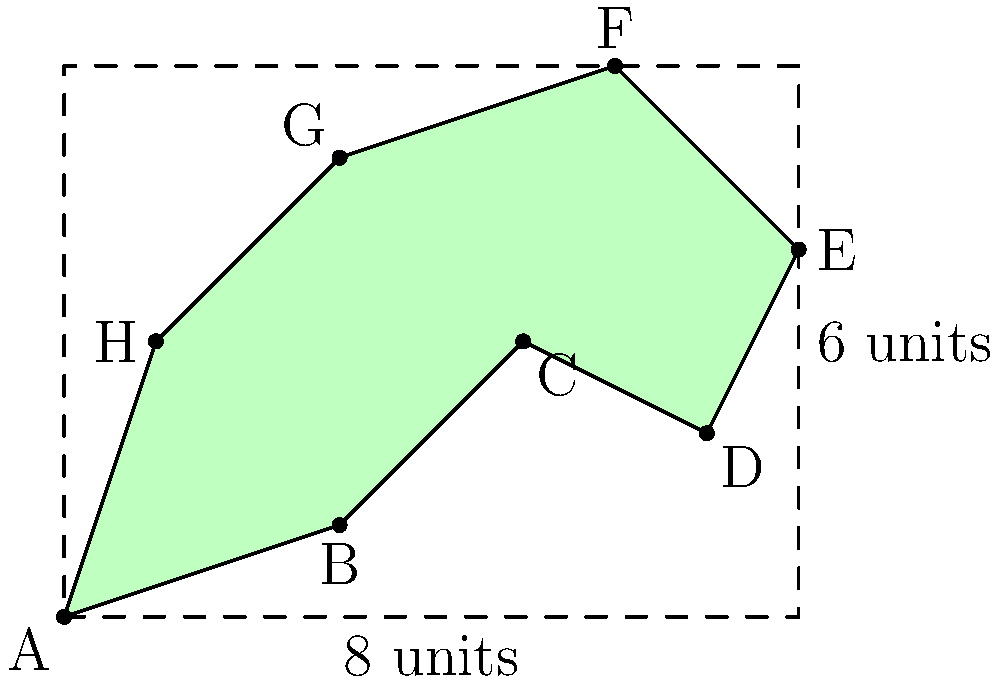During your urban exploration, you come across an irregularly shaped park shown in the diagram. The park is enclosed within a rectangular area of 8 units by 6 units. Using geometric approximations, estimate the area of the park in square units. Round your answer to the nearest whole number. To estimate the area of this irregularly shaped park, we can use the following approach:

1) First, we recognize that the park is enclosed within a rectangle of 8 units by 6 units. The area of this rectangle is:

   $$A_{rectangle} = 8 \times 6 = 48$$ square units

2) Now, we need to estimate how much of this rectangle the park actually occupies. We can do this by dividing the park into approximate triangles and trapezoids:

   - Triangle ABH
   - Trapezoid BCDH
   - Triangle DEF
   - Triangle FGH

3) Estimating the areas of these shapes:

   - Triangle ABH: Approximately $\frac{1}{2} \times 3 \times 3 = 4.5$ sq units
   - Trapezoid BCDH: Approximately $\frac{1}{2}(4+2) \times 4 = 12$ sq units
   - Triangle DEF: Approximately $\frac{1}{2} \times 2 \times 2 = 2$ sq units
   - Triangle FGH: Approximately $\frac{1}{2} \times 5 \times 3 = 7.5$ sq units

4) Sum these areas:

   $$A_{park} \approx 4.5 + 12 + 2 + 7.5 = 26$$ square units

5) As a percentage of the total rectangle:

   $$\frac{26}{48} \approx 0.54$$ or about 54% of the rectangle

6) This estimation suggests the park occupies slightly more than half of the rectangular area.

Rounding to the nearest whole number, our estimate for the park's area is 26 square units.
Answer: 26 square units 